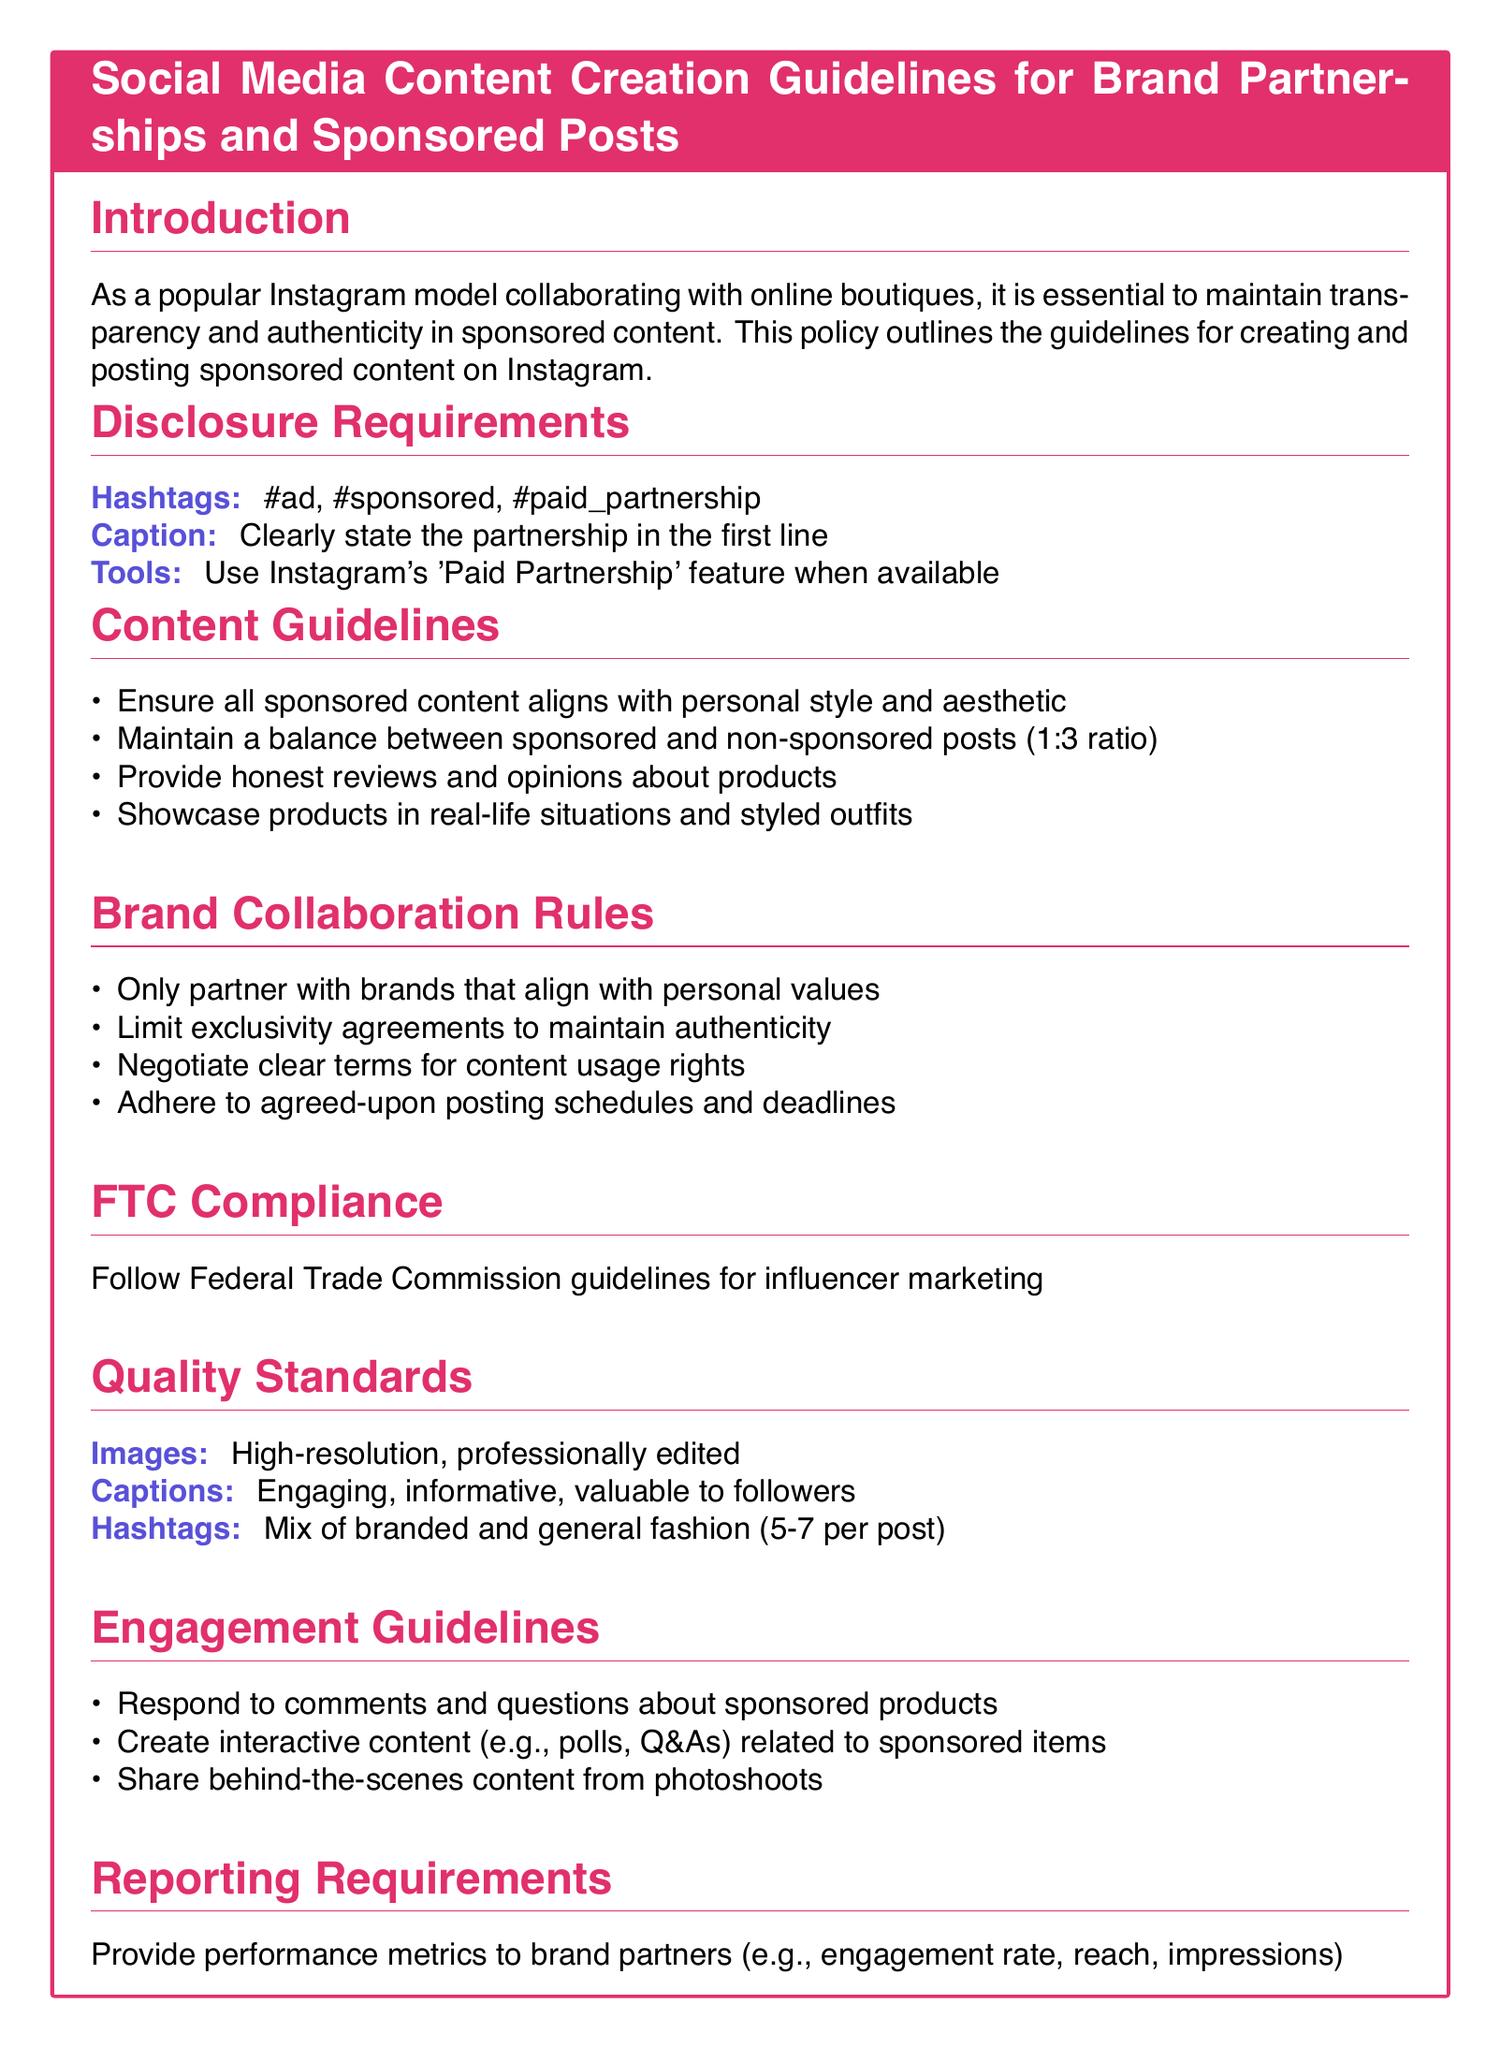What are the required hashtags for disclosure? The required hashtags for disclosure are found in the Disclosure Requirements section.
Answer: #ad, #sponsored, #paid_partnership What is the required post ratio of sponsored to non-sponsored content? The document specifies a balance between sponsored and non-sponsored posts in the Content Guidelines section.
Answer: 1:3 What should you include in the first line of the caption? The document states that the partnership should be clearly stated in the caption.
Answer: Partnership What is the image quality standard for sponsored posts? The Quality Standards section indicates the expected quality of images used in sponsored posts.
Answer: High-resolution, professionally edited What should you negotiate regarding brand collaborations? The Brand Collaboration Rules section mentions the need to negotiate clear terms.
Answer: Content usage rights How many hashtags should be used per post? The document provides guidance in the Quality Standards section on the number of hashtags to use.
Answer: 5-7 What type of content should be shared to engage followers? The Engagement Guidelines suggest a specific type of content to create interaction.
Answer: Interactive content What must be adhered to in brand collaborations? The Brand Collaboration Rules outline specific commitments that must be followed.
Answer: Agreed-upon posting schedules and deadlines What guidelines should influencers follow for legal compliance? The document mentions specific regulations that must be followed in the FTC Compliance section.
Answer: Federal Trade Commission guidelines 